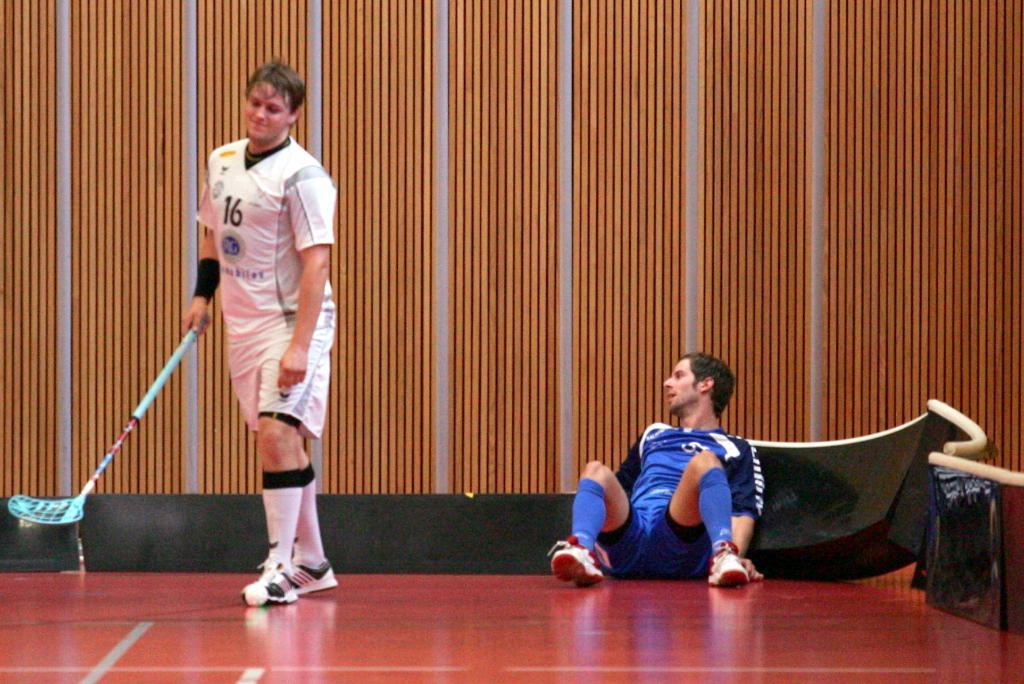What is the man in the image doing? There is a man sitting on the floor in the image. What is the man on the left side of the image holding? The man on the left side of the image is holding a stick. What can be seen in the background of the image? There is a wall in the background of the image. What is on the wall in the background? There are objects visible on the wall in the background. What type of songs is the man on the right side of the image singing? There is no man on the right side of the image, and no singing is depicted in the image. What country is the image taken in? The provided facts do not give any information about the country where the image was taken. 